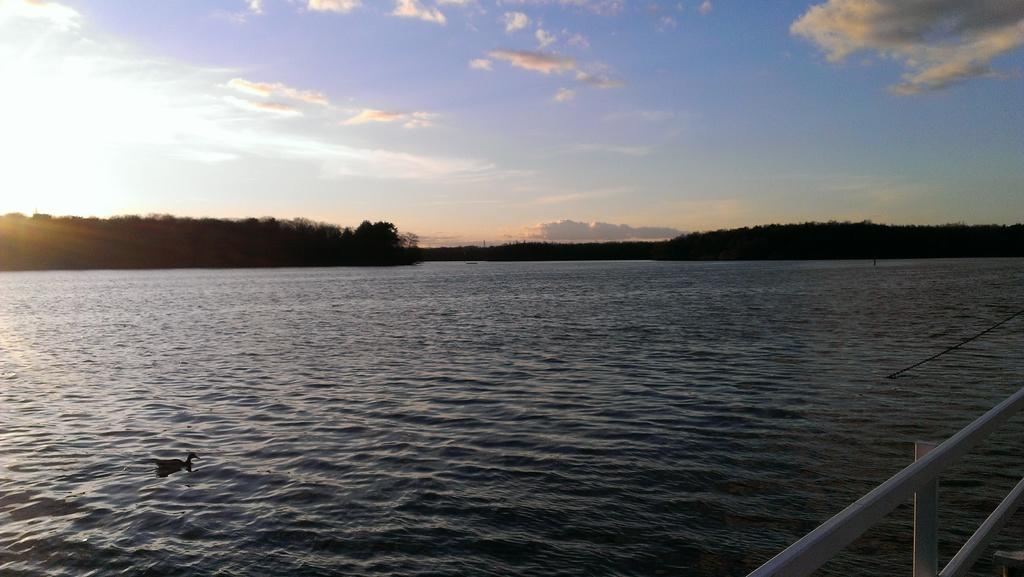What is floating in the river in the image? There is a duck floating in the river in the image. What type of vegetation can be seen in the image? There are trees visible in the image. What type of barrier is present in the image? There is fencing in the image. What is the condition of the sky in the image? The sky is clouded in the image. How does the duck increase its heart rate in the image? There is no information about the duck's heart rate in the image, and it does not show any action that would cause an increase in heart rate. 